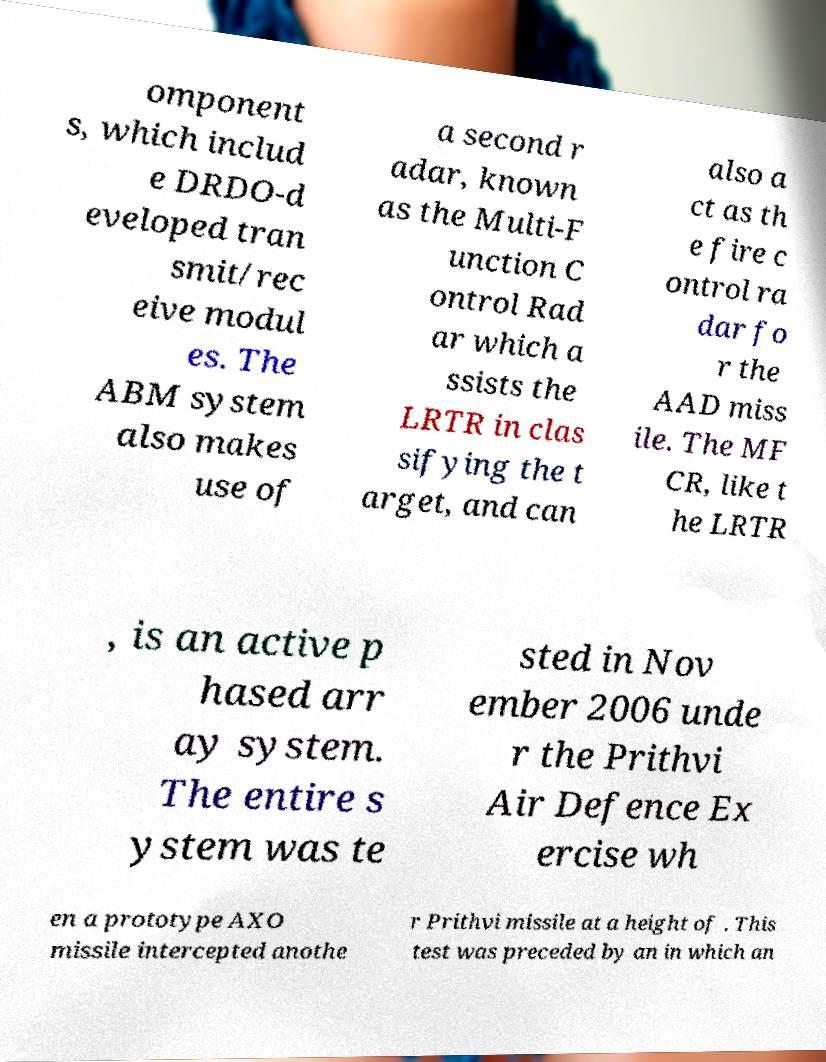Can you read and provide the text displayed in the image?This photo seems to have some interesting text. Can you extract and type it out for me? omponent s, which includ e DRDO-d eveloped tran smit/rec eive modul es. The ABM system also makes use of a second r adar, known as the Multi-F unction C ontrol Rad ar which a ssists the LRTR in clas sifying the t arget, and can also a ct as th e fire c ontrol ra dar fo r the AAD miss ile. The MF CR, like t he LRTR , is an active p hased arr ay system. The entire s ystem was te sted in Nov ember 2006 unde r the Prithvi Air Defence Ex ercise wh en a prototype AXO missile intercepted anothe r Prithvi missile at a height of . This test was preceded by an in which an 